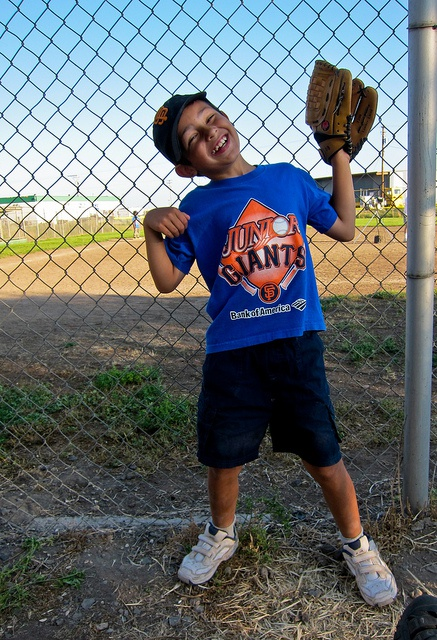Describe the objects in this image and their specific colors. I can see people in lightblue, black, navy, maroon, and darkblue tones, baseball glove in lightblue, black, maroon, and gray tones, and people in lightblue, khaki, lightgray, and tan tones in this image. 